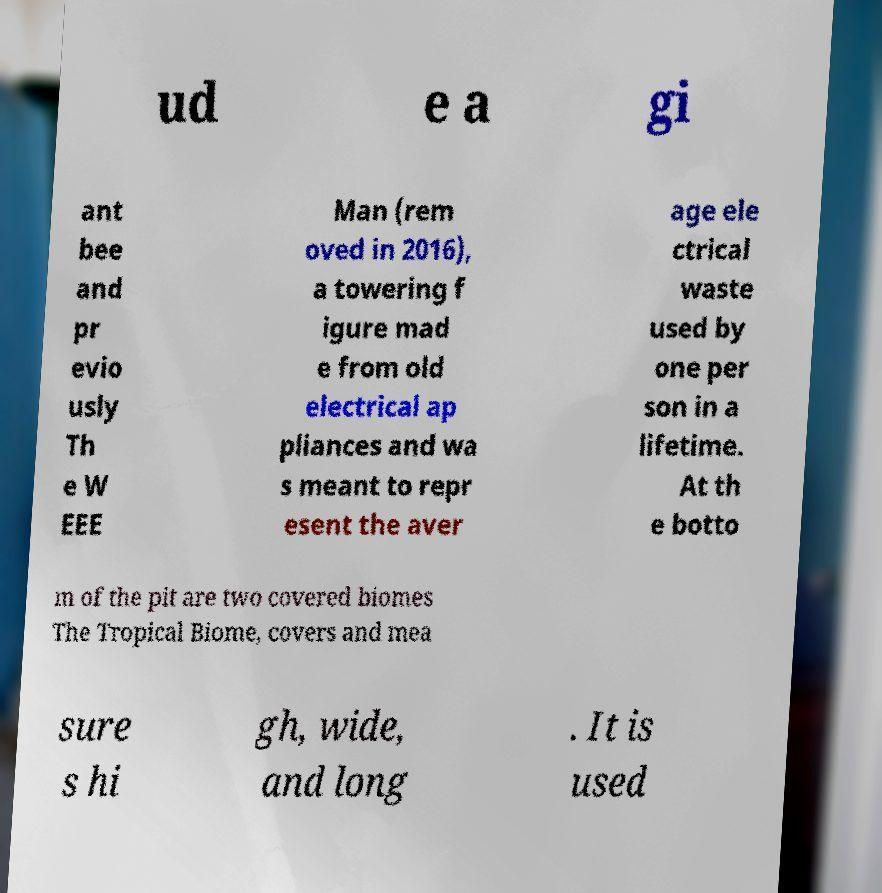I need the written content from this picture converted into text. Can you do that? ud e a gi ant bee and pr evio usly Th e W EEE Man (rem oved in 2016), a towering f igure mad e from old electrical ap pliances and wa s meant to repr esent the aver age ele ctrical waste used by one per son in a lifetime. At th e botto m of the pit are two covered biomes The Tropical Biome, covers and mea sure s hi gh, wide, and long . It is used 